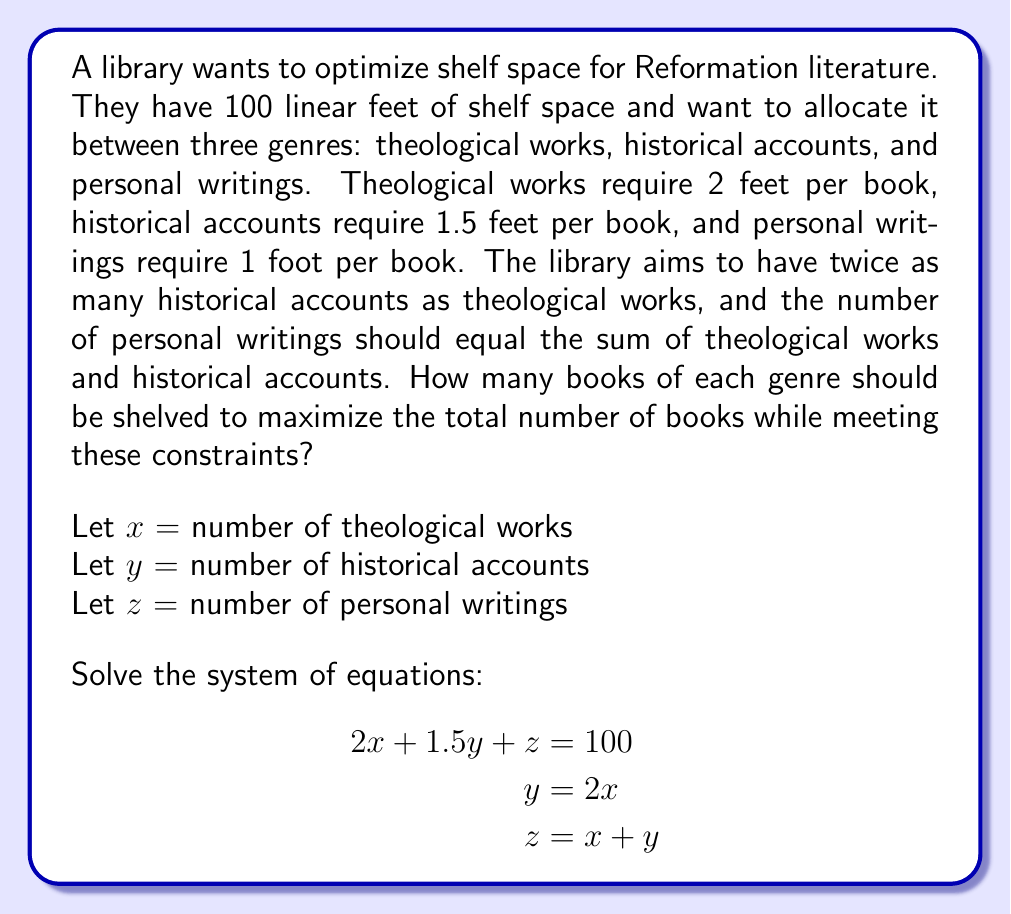Can you solve this math problem? 1) We start with three equations:
   $$2x + 1.5y + z = 100$$ (shelf space constraint)
   $$y = 2x$$ (historical accounts constraint)
   $$z = x + y$$ (personal writings constraint)

2) Substitute $y = 2x$ into the third equation:
   $$z = x + 2x = 3x$$

3) Now substitute both $y = 2x$ and $z = 3x$ into the first equation:
   $$2x + 1.5(2x) + 3x = 100$$

4) Simplify:
   $$2x + 3x + 3x = 100$$
   $$8x = 100$$

5) Solve for $x$:
   $$x = 100 / 8 = 12.5$$

6) Since we can't have fractional books, we round down to 12 theological works.

7) Now calculate $y$ and $z$:
   $y = 2x = 2(12) = 24$ historical accounts
   $z = x + y = 12 + 24 = 36$ personal writings

8) Verify the shelf space constraint:
   $$2(12) + 1.5(24) + 1(36) = 24 + 36 + 36 = 96$$ feet (which is ≤ 100)

This solution maximizes the total number of books (12 + 24 + 36 = 72) while meeting all constraints and staying within the available shelf space.
Answer: 12 theological works, 24 historical accounts, 36 personal writings 